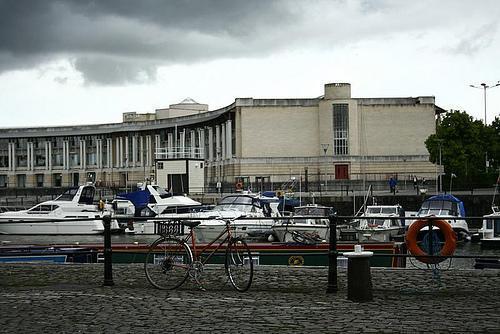How many types of vehicles are in the photo?
Give a very brief answer. 2. How many boats can be seen?
Give a very brief answer. 2. 